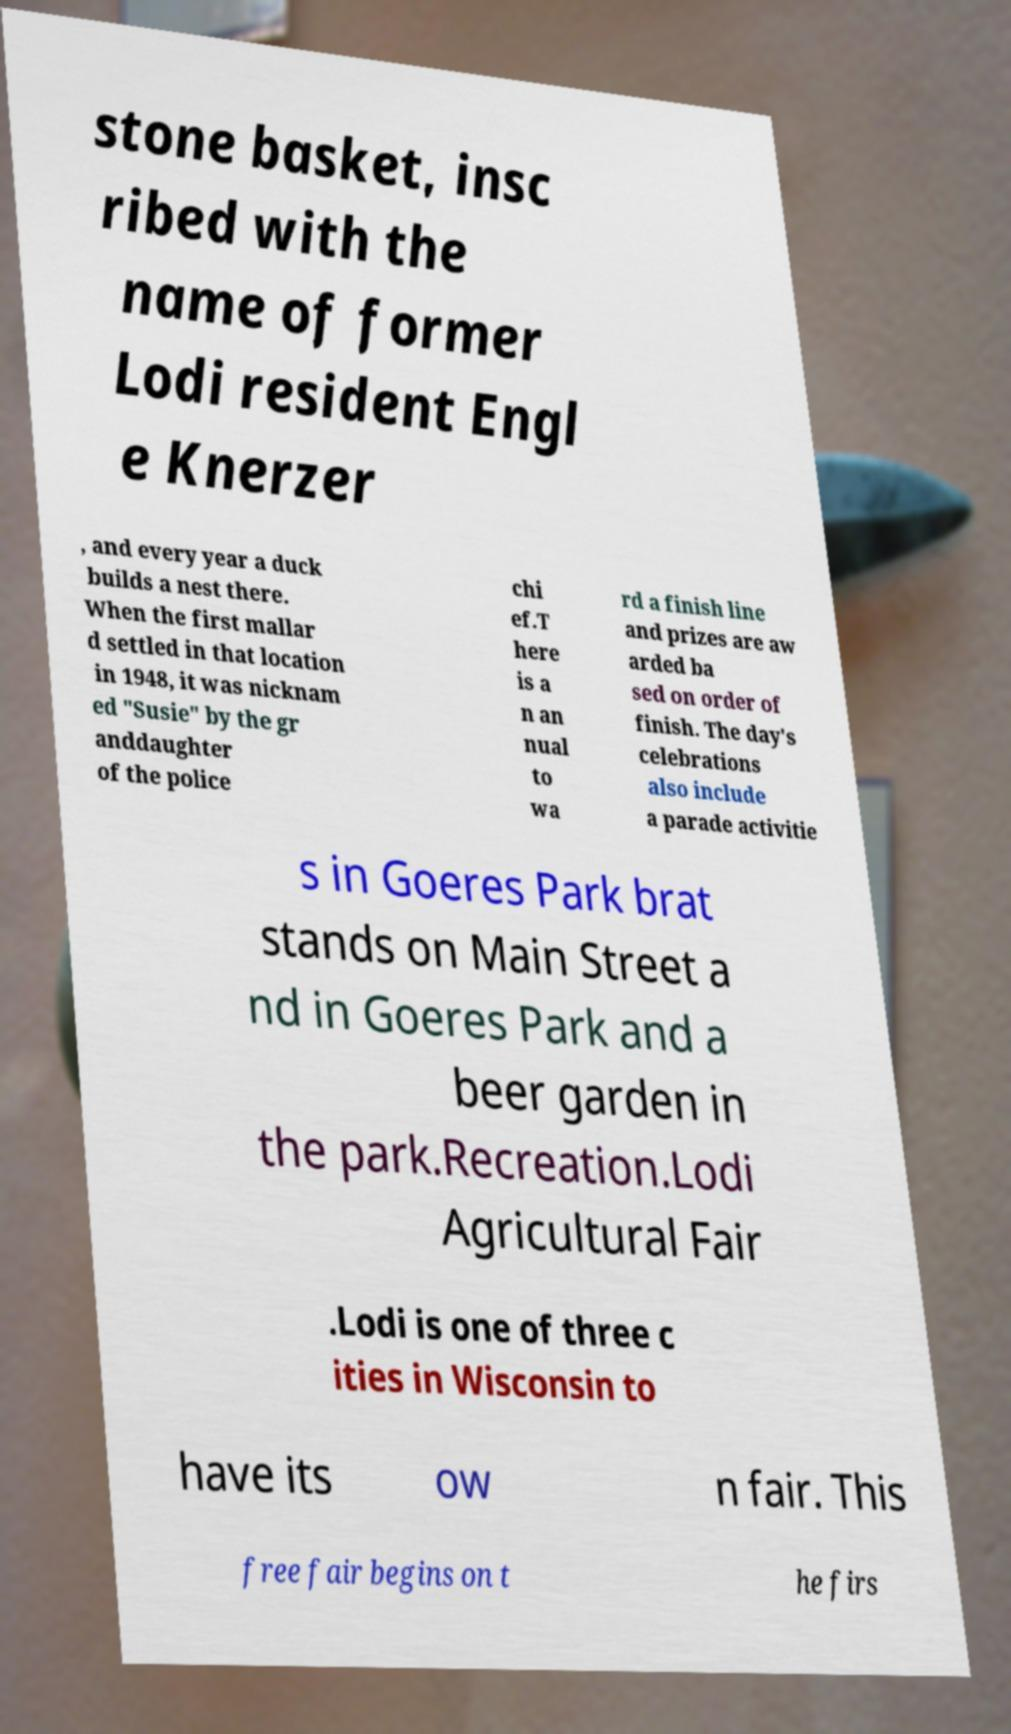Can you read and provide the text displayed in the image?This photo seems to have some interesting text. Can you extract and type it out for me? stone basket, insc ribed with the name of former Lodi resident Engl e Knerzer , and every year a duck builds a nest there. When the first mallar d settled in that location in 1948, it was nicknam ed "Susie" by the gr anddaughter of the police chi ef.T here is a n an nual to wa rd a finish line and prizes are aw arded ba sed on order of finish. The day's celebrations also include a parade activitie s in Goeres Park brat stands on Main Street a nd in Goeres Park and a beer garden in the park.Recreation.Lodi Agricultural Fair .Lodi is one of three c ities in Wisconsin to have its ow n fair. This free fair begins on t he firs 